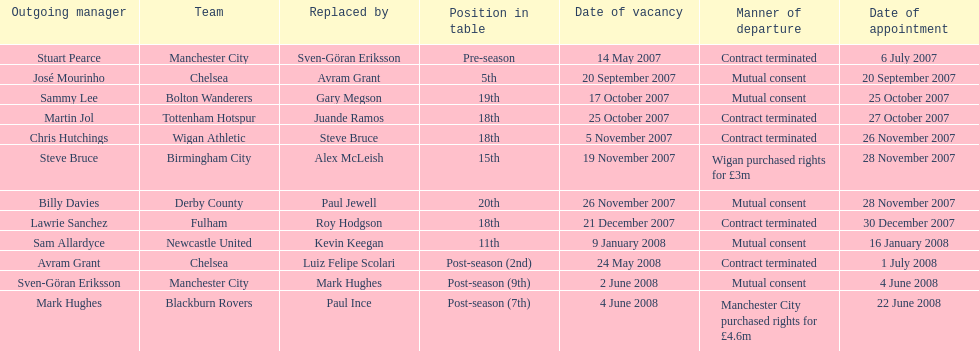What team is listed after manchester city? Chelsea. 